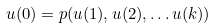<formula> <loc_0><loc_0><loc_500><loc_500>u ( 0 ) = p ( u ( 1 ) , u ( 2 ) , \dots u ( k ) )</formula> 